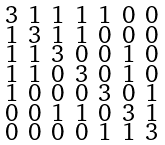<formula> <loc_0><loc_0><loc_500><loc_500>\begin{smallmatrix} 3 & 1 & 1 & 1 & 1 & 0 & 0 \\ 1 & 3 & 1 & 1 & 0 & 0 & 0 \\ 1 & 1 & 3 & 0 & 0 & 1 & 0 \\ 1 & 1 & 0 & 3 & 0 & 1 & 0 \\ 1 & 0 & 0 & 0 & 3 & 0 & 1 \\ 0 & 0 & 1 & 1 & 0 & 3 & 1 \\ 0 & 0 & 0 & 0 & 1 & 1 & 3 \end{smallmatrix}</formula> 